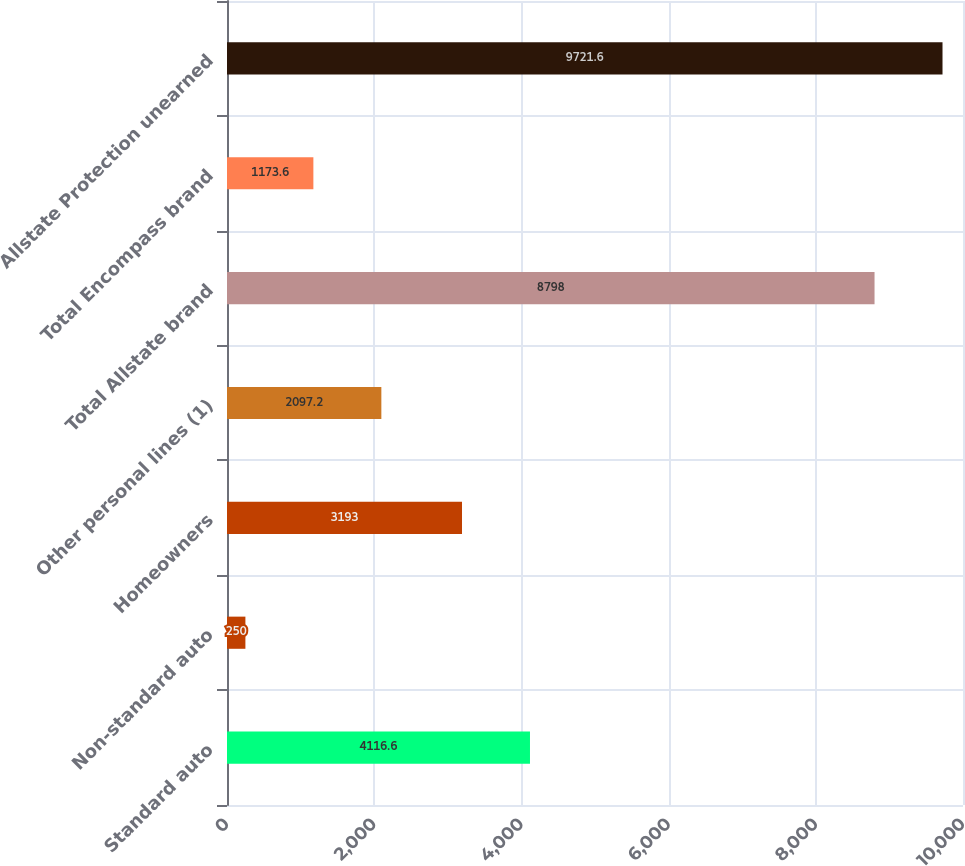Convert chart to OTSL. <chart><loc_0><loc_0><loc_500><loc_500><bar_chart><fcel>Standard auto<fcel>Non-standard auto<fcel>Homeowners<fcel>Other personal lines (1)<fcel>Total Allstate brand<fcel>Total Encompass brand<fcel>Allstate Protection unearned<nl><fcel>4116.6<fcel>250<fcel>3193<fcel>2097.2<fcel>8798<fcel>1173.6<fcel>9721.6<nl></chart> 